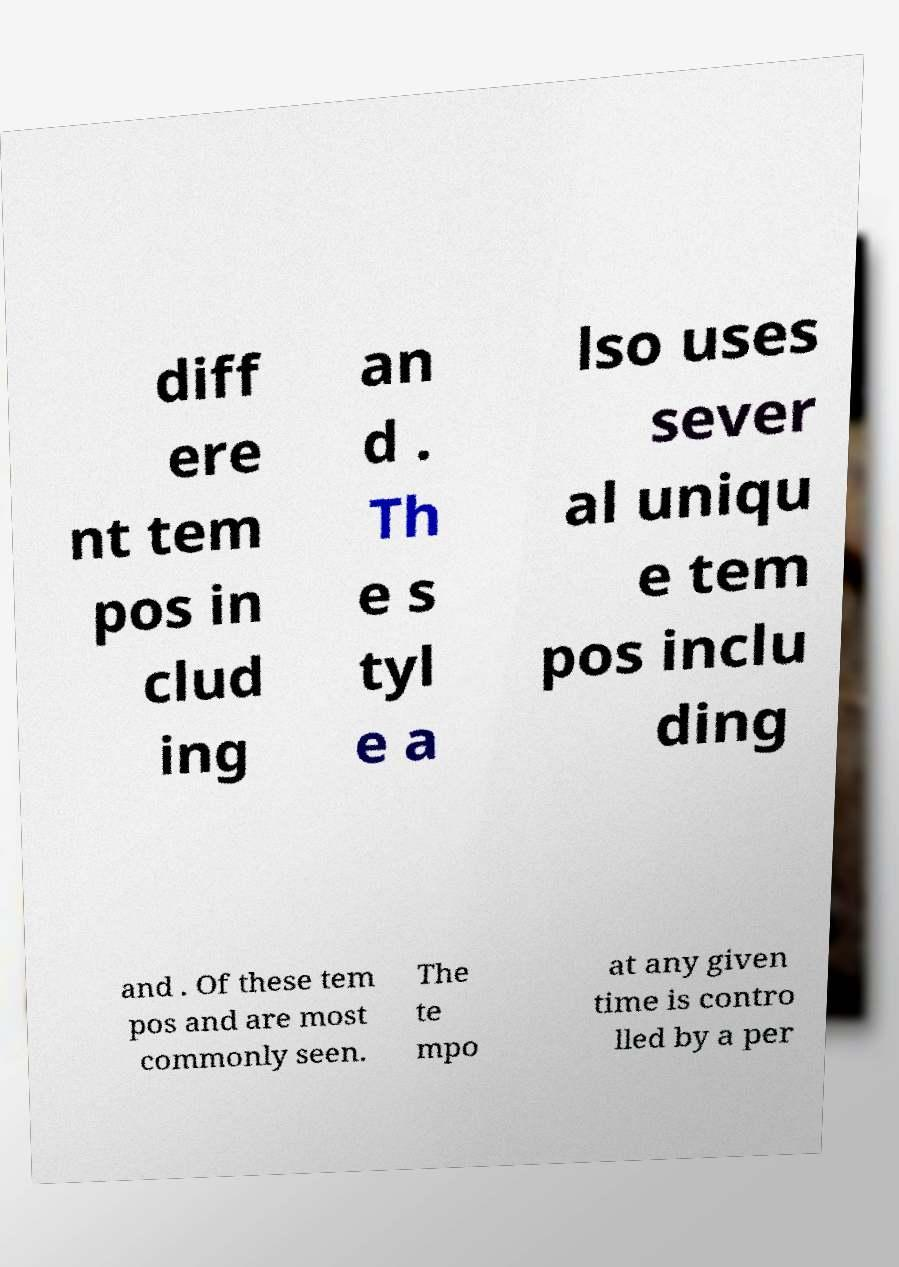For documentation purposes, I need the text within this image transcribed. Could you provide that? diff ere nt tem pos in clud ing an d . Th e s tyl e a lso uses sever al uniqu e tem pos inclu ding and . Of these tem pos and are most commonly seen. The te mpo at any given time is contro lled by a per 